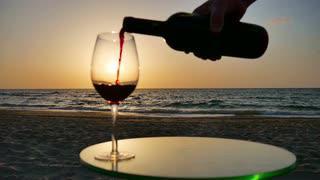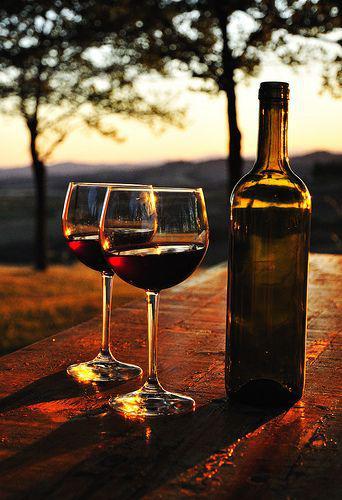The first image is the image on the left, the second image is the image on the right. Analyze the images presented: Is the assertion "In one image, red wine is being poured into a wine glass" valid? Answer yes or no. Yes. The first image is the image on the left, the second image is the image on the right. Given the left and right images, does the statement "At least one image contains a wine bottle, being poured into a glass, with a sunset in the background." hold true? Answer yes or no. Yes. 